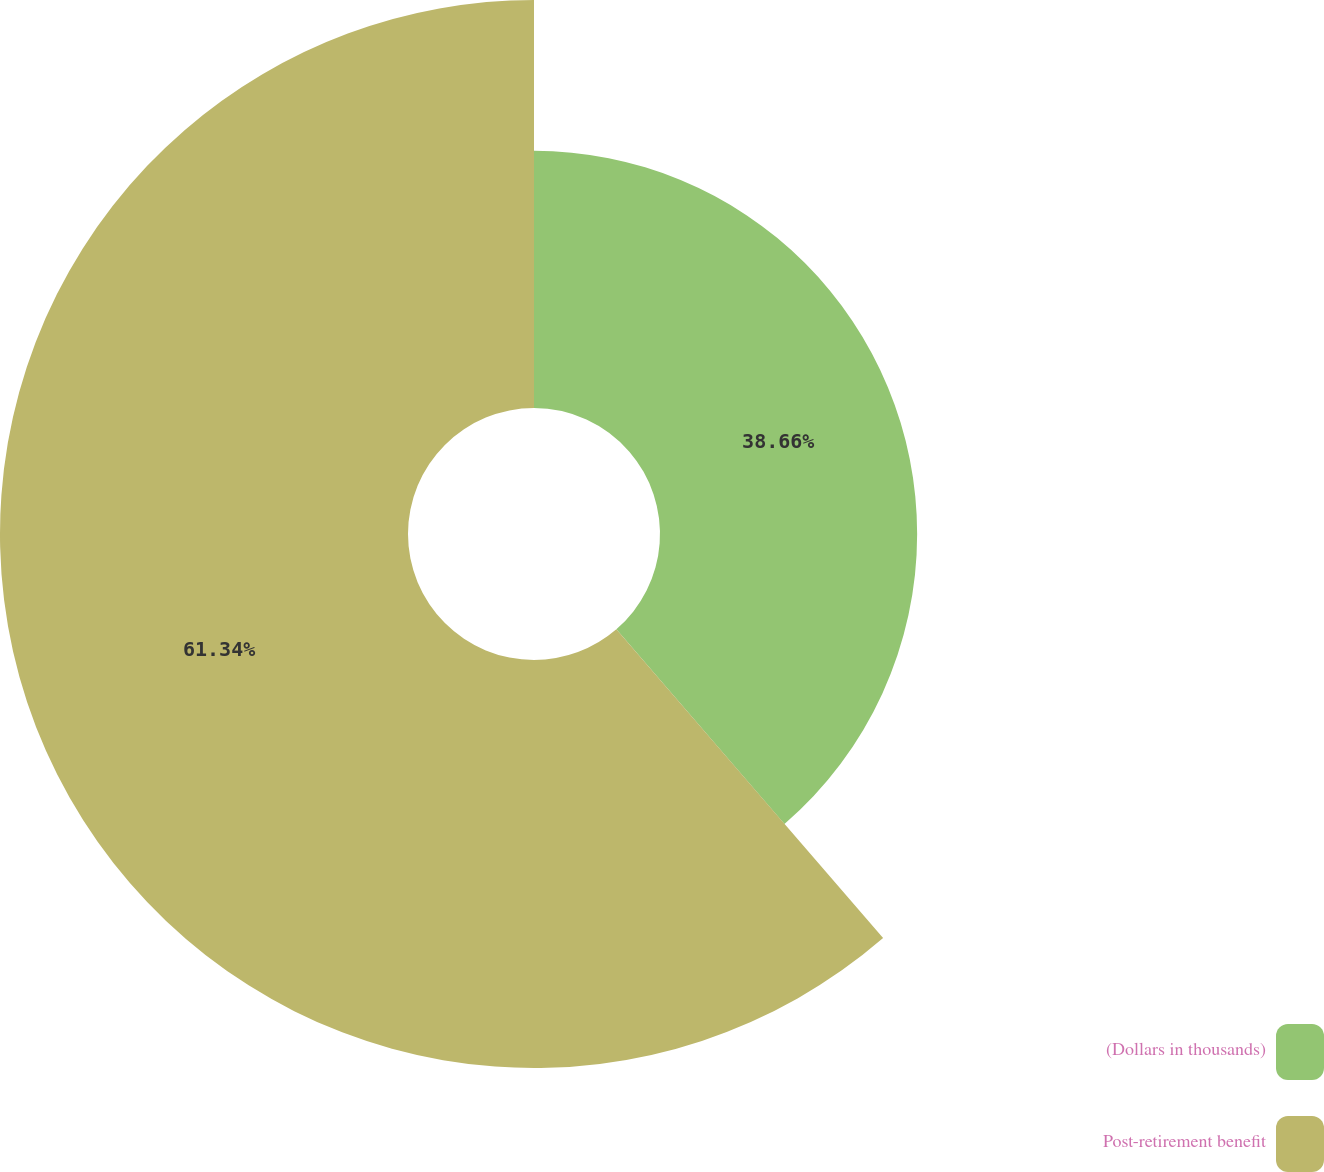Convert chart. <chart><loc_0><loc_0><loc_500><loc_500><pie_chart><fcel>(Dollars in thousands)<fcel>Post-retirement benefit<nl><fcel>38.66%<fcel>61.34%<nl></chart> 